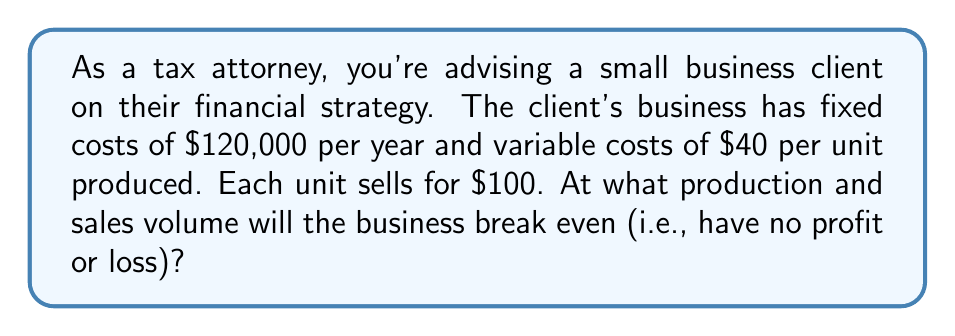Can you answer this question? Let's approach this step-by-step:

1) First, let's define our variables:
   $x$ = number of units produced and sold
   $FC$ = fixed costs
   $VC$ = variable cost per unit
   $P$ = price per unit

2) We know:
   $FC = \$120,000$
   $VC = \$40$ per unit
   $P = \$100$ per unit

3) The break-even point occurs when total revenue equals total costs:
   $\text{Total Revenue} = \text{Total Costs}$

4) We can express this as an equation:
   $Px = FC + VCx$

5) Substituting our known values:
   $100x = 120,000 + 40x$

6) Simplify by subtracting $40x$ from both sides:
   $60x = 120,000$

7) Divide both sides by 60:
   $x = 2,000$

Therefore, the business will break even when it produces and sells 2,000 units.

8) To verify, let's calculate revenue and costs at this point:
   Revenue: $2,000 \times \$100 = \$200,000$
   Costs: $\$120,000 + (2,000 \times \$40) = \$200,000$

Indeed, revenue equals costs at 2,000 units, confirming our break-even point.
Answer: 2,000 units 